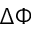<formula> <loc_0><loc_0><loc_500><loc_500>\Delta \Phi</formula> 